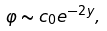Convert formula to latex. <formula><loc_0><loc_0><loc_500><loc_500>\varphi \sim c _ { 0 } e ^ { - 2 y } ,</formula> 